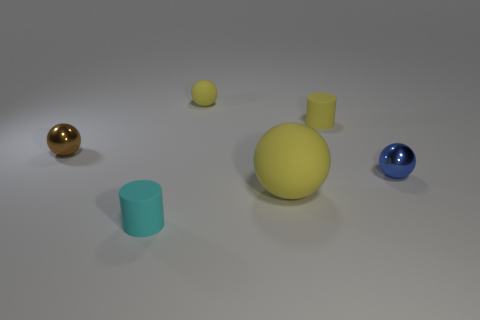Subtract 1 balls. How many balls are left? 3 Add 2 cyan cylinders. How many objects exist? 8 Subtract all spheres. How many objects are left? 2 Subtract 0 gray balls. How many objects are left? 6 Subtract all tiny cylinders. Subtract all yellow balls. How many objects are left? 2 Add 1 yellow matte things. How many yellow matte things are left? 4 Add 6 matte cylinders. How many matte cylinders exist? 8 